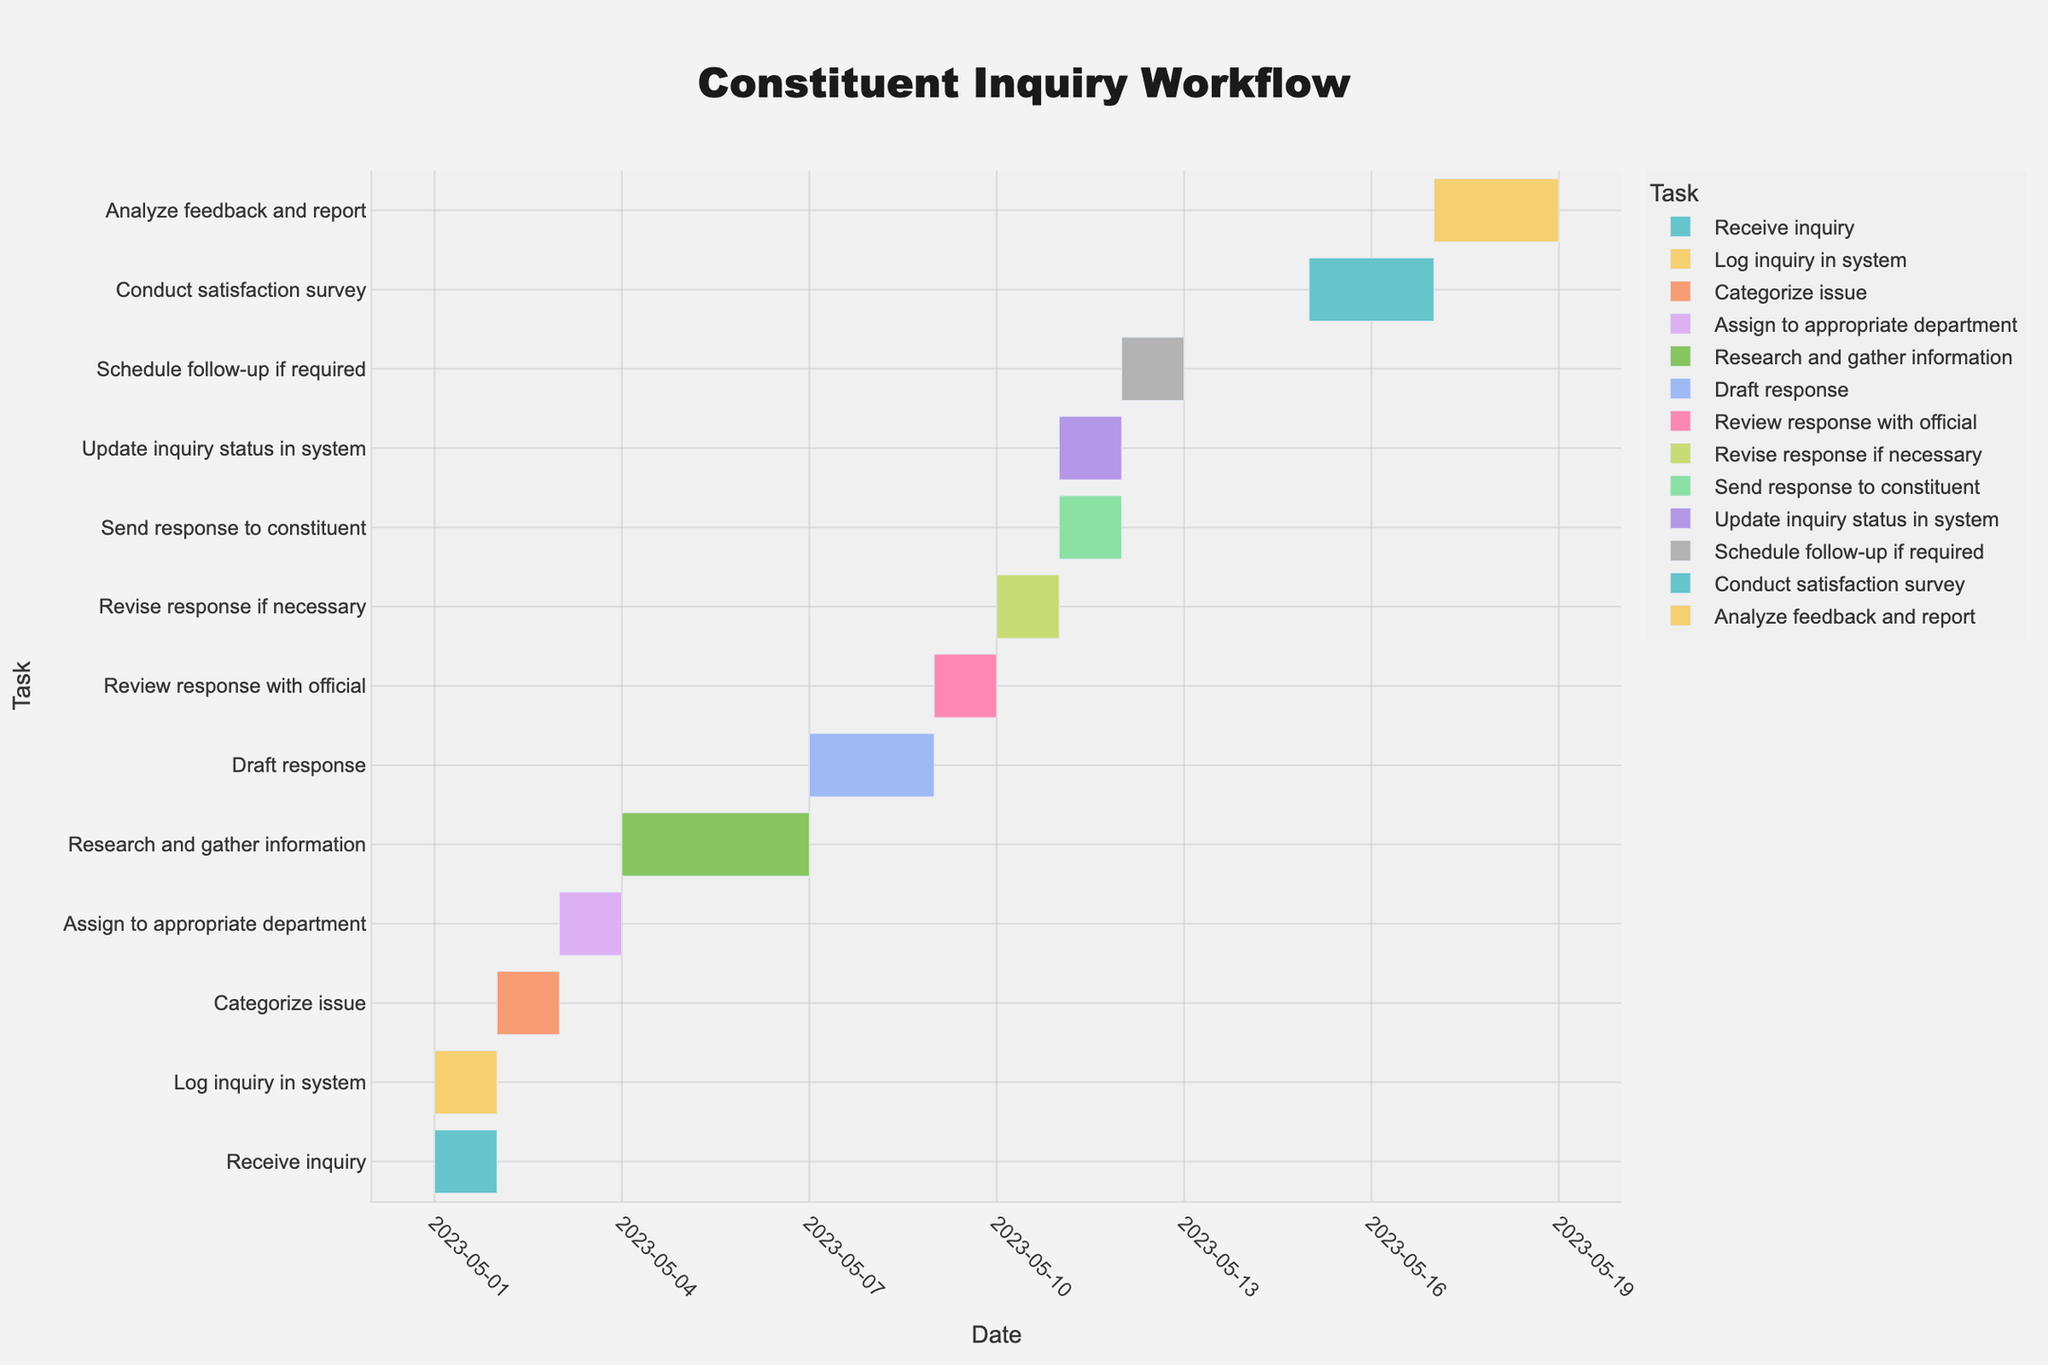What is the title of the Gantt Chart? The title of the Gantt Chart is found at the top of the figure. It is visibly larger and centered to draw attention.
Answer: Constituent Inquiry Workflow How many tasks are involved in the workflow? In the Gantt Chart, each task is listed on the y-axis. By counting these tasks, we determine the total number.
Answer: 13 Which task starts on May 3, 2023? The Gantt Chart shows the start date of tasks on the x-axis and aligns them with the specific task on the y-axis. Locate May 3, 2023, on the x-axis and find the corresponding task on the y-axis.
Answer: Assign to appropriate department What is the total duration from receiving the inquiry to sending a response to the constituent? Measure the timeline from the start date of "Receive inquiry" (May 1) to the end date of "Send response to constituent" (May 11). The duration is the difference in days.
Answer: 10 days Which task takes the longest duration, and how many days does it take? The duration of each task is visible in the horizontal bar's length. Identify the task with the longest bar and note its duration.
Answer: Research and gather information, 3 days How does the duration of "Draft response" compare to "Review response with official"? Locate the two tasks on the y-axis and compare the length of their respective bars. "Draft response" lasts from May 7 to May 9 (2 days), and "Review response with official" lasts on May 9 (1 day).
Answer: Draft response is longer by 1 day When is the "Conduct satisfaction survey" scheduled to start and end? Locate "Conduct satisfaction survey" on the y-axis and refer to the corresponding start and end dates on the x-axis.
Answer: Starts on May 15, ends on May 17 What is the average duration of the tasks in the workflow? Sum the duration of all tasks and divide by the number of tasks. The durations are 1, 1, 1, 1, 3, 2, 1, 1, 1, 1, 1, 2, 2. (1+1+1+1+3+2+1+1+1+1+1+2+2) / 13 = 18/13.
Answer: 1.38 days Which task occurs last in the workflow? The order and dates of the tasks are shown on the Gantt Chart. The last task in the sequence is the one that ends the latest.
Answer: Analyze feedback and report Are there any tasks with the same start and end dates? If so, name them. Check for tasks that have bars beginning and finishing at the same point on the x-axis. These indicate a duration of 1 day.
Answer: Receive inquiry, Log inquiry in system, Assign to appropriate department, Review response with official, Revise response if necessary, Send response to constituent, Update inquiry status in system, Schedule follow-up 